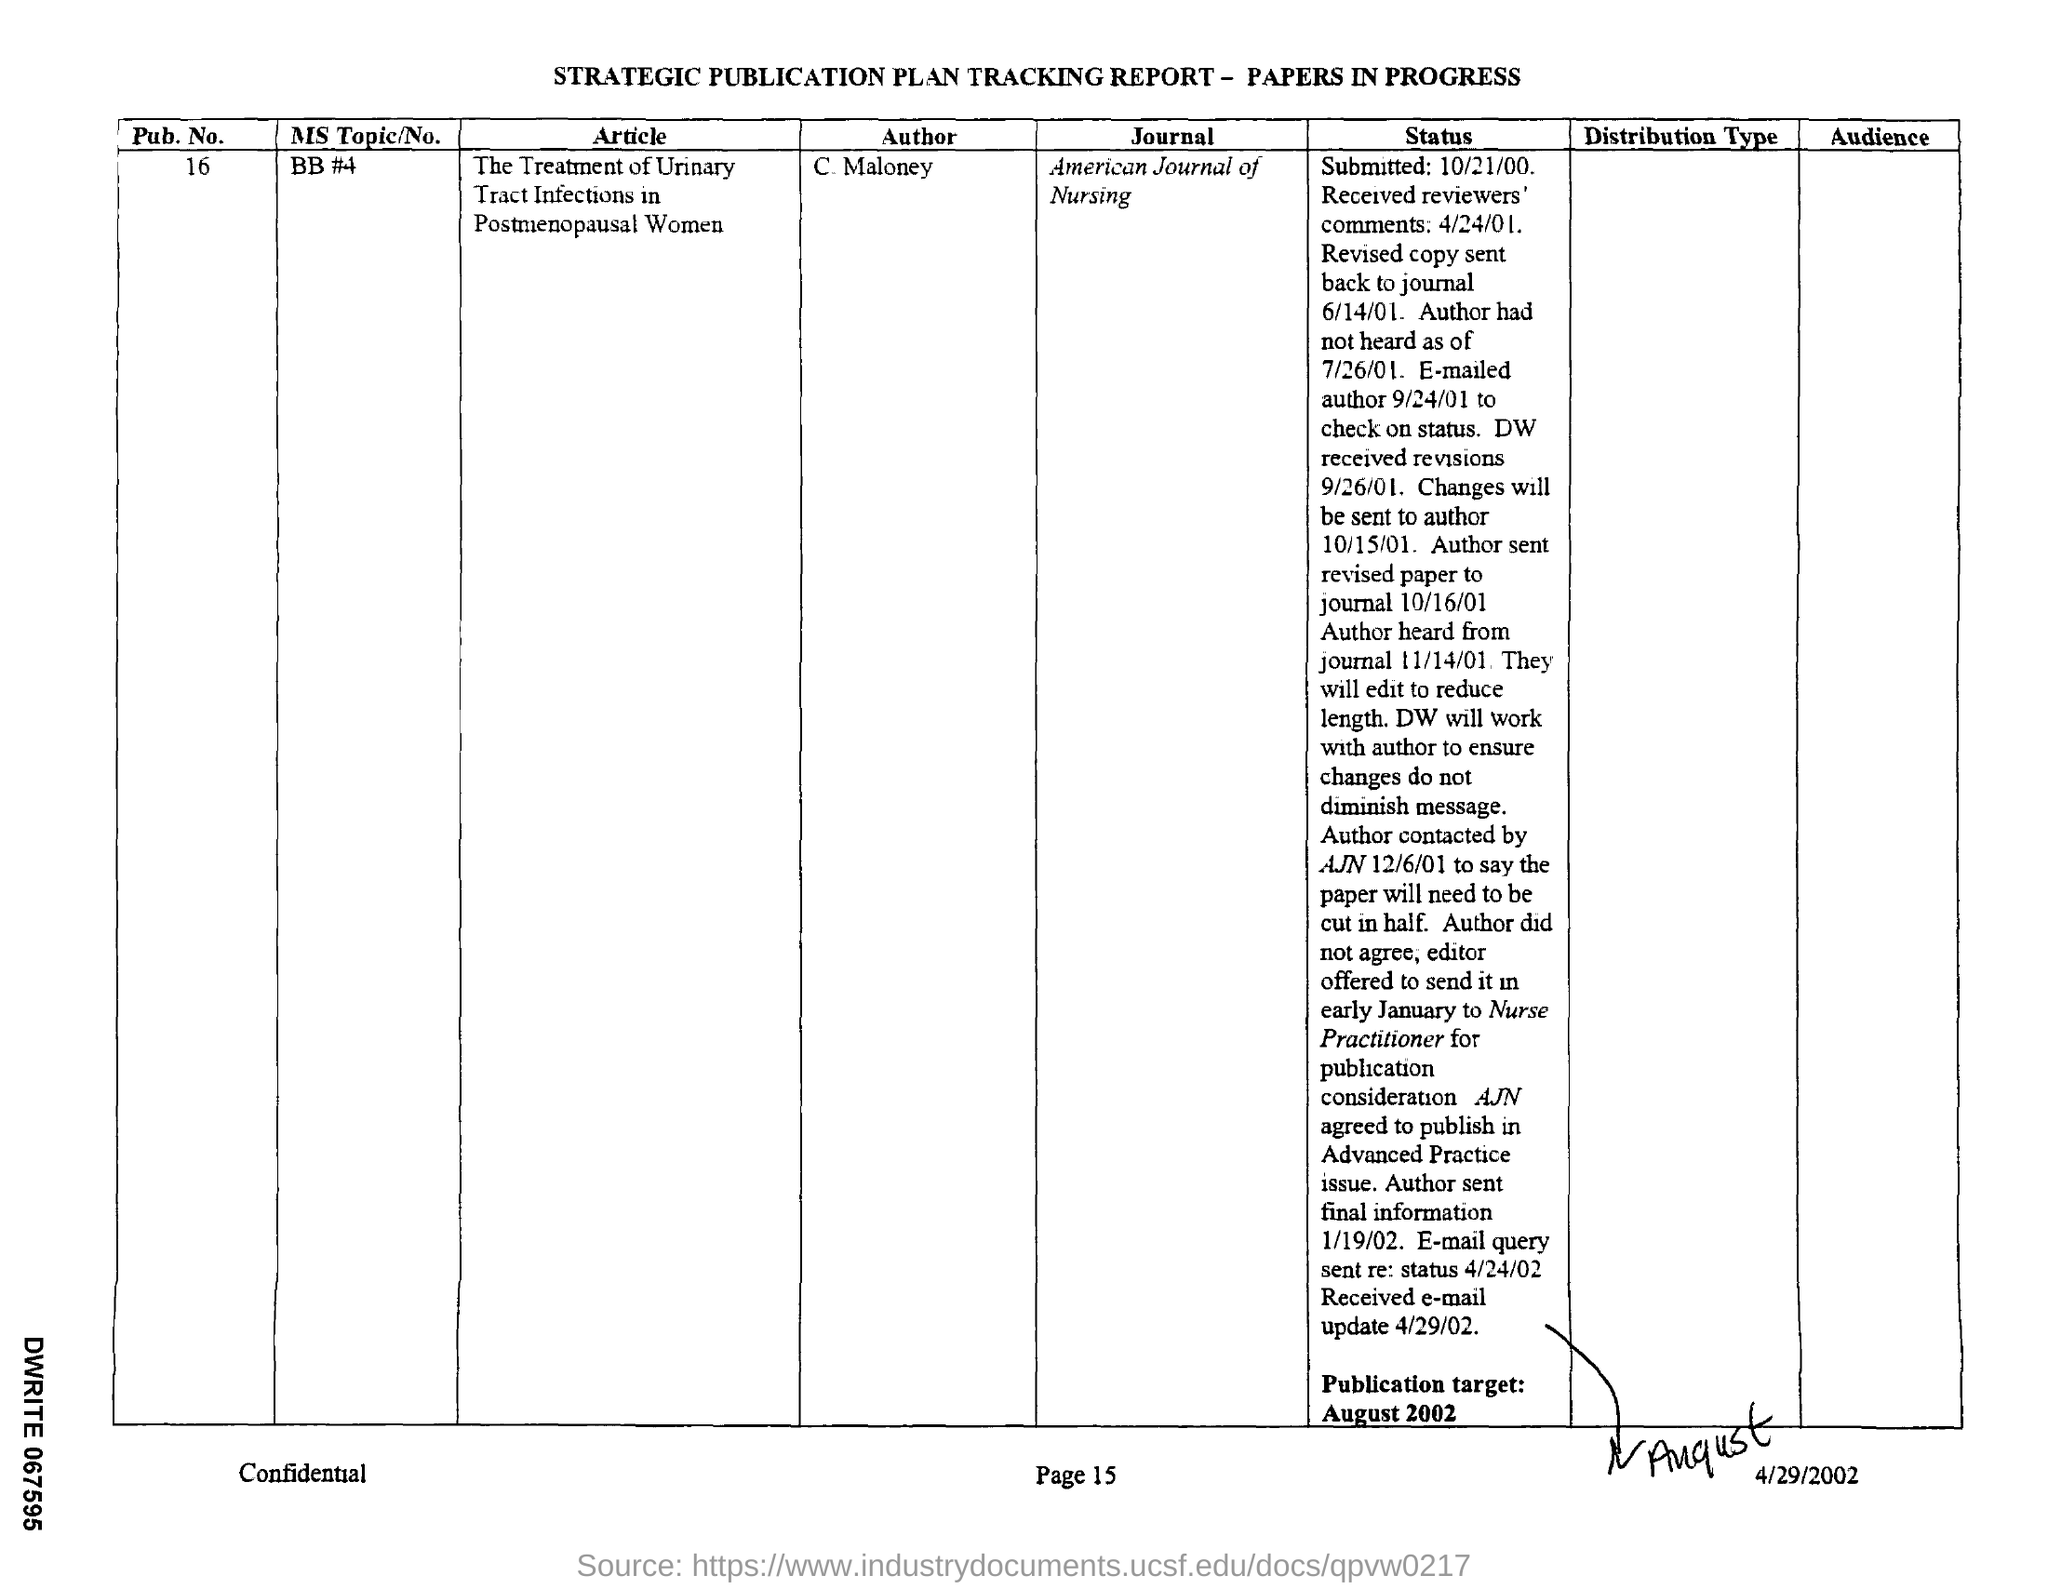Who is the author mentioned in the given tracking report ?
Offer a very short reply. C. Maloney. What is the journal mentioned in the tracking report ?
Give a very brief answer. American Journal of Nursing. What is the name of the article mentioned in the given tracking report ?
Provide a succinct answer. The Treatment of Urinary Tract Infections in Postmenopausal Women. What is the pub.no. mentioned in the report ?
Provide a short and direct response. 16. When is the publication target given in the report ?
Offer a terse response. August 2002. 